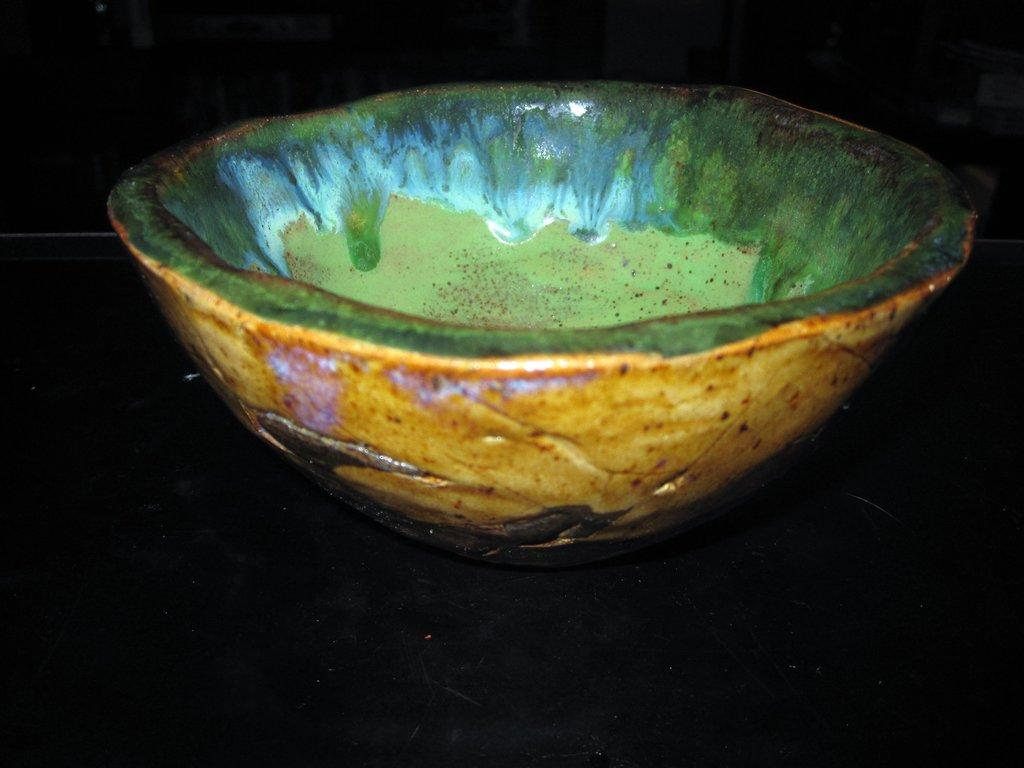What is present in the image? There is a bowl in the image. Where is the bowl located? The bowl is placed on a surface. What type of machine is visible in the image? There is no machine present in the image; it only features a bowl placed on a surface. 